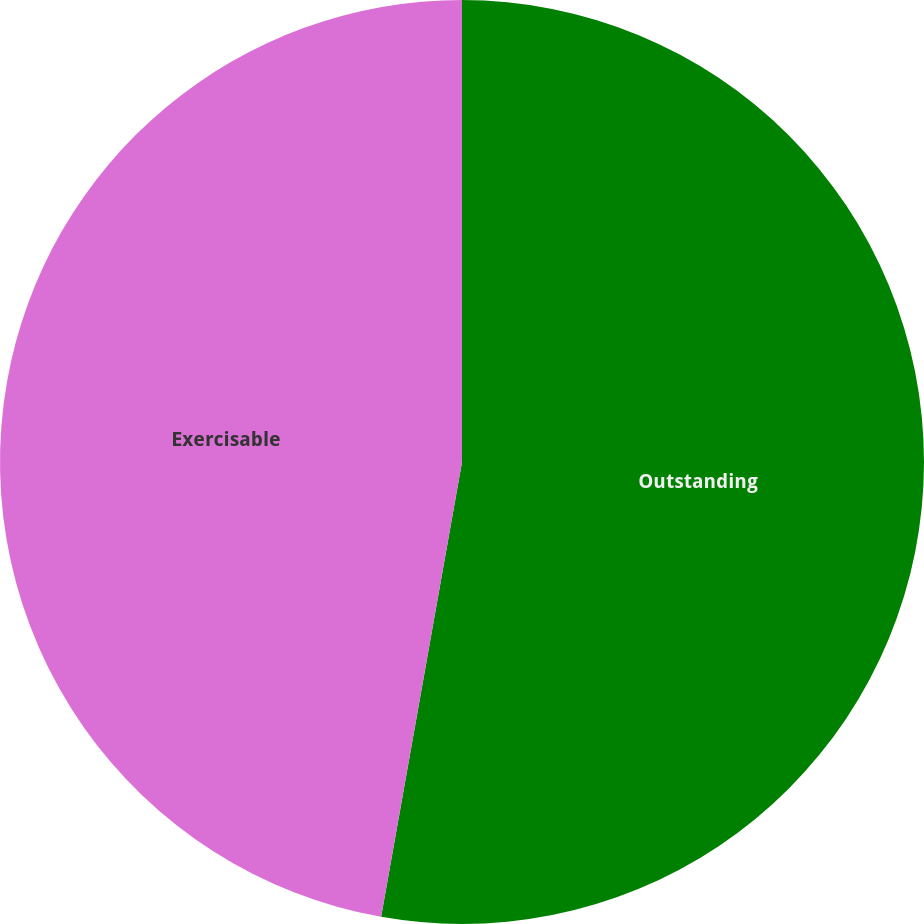Convert chart to OTSL. <chart><loc_0><loc_0><loc_500><loc_500><pie_chart><fcel>Outstanding<fcel>Exercisable<nl><fcel>52.8%<fcel>47.2%<nl></chart> 